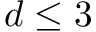<formula> <loc_0><loc_0><loc_500><loc_500>d \leq 3</formula> 